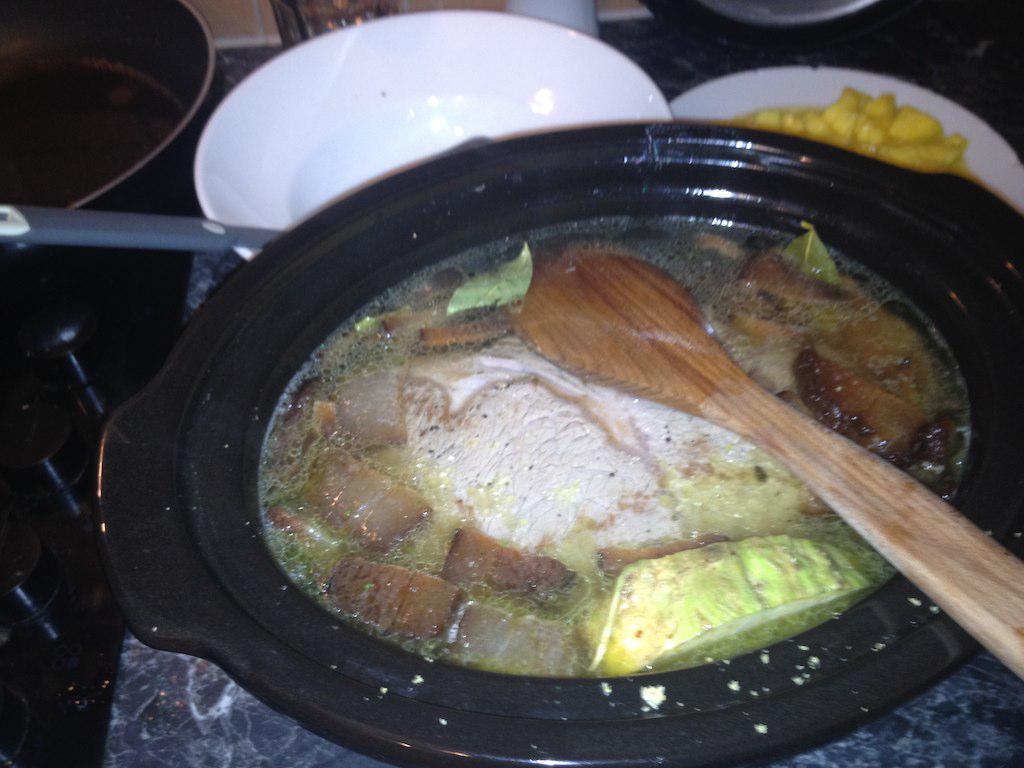In one or two sentences, can you explain what this image depicts? In the center of a image there is a bowl with some food items in it. There is a spoon, besides it there is a empty bowl with a spoon. 